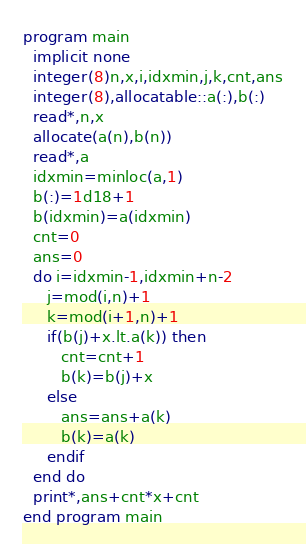Convert code to text. <code><loc_0><loc_0><loc_500><loc_500><_FORTRAN_>program main
  implicit none
  integer(8)n,x,i,idxmin,j,k,cnt,ans
  integer(8),allocatable::a(:),b(:)
  read*,n,x
  allocate(a(n),b(n))
  read*,a
  idxmin=minloc(a,1)
  b(:)=1d18+1
  b(idxmin)=a(idxmin)
  cnt=0
  ans=0
  do i=idxmin-1,idxmin+n-2
     j=mod(i,n)+1
     k=mod(i+1,n)+1
     if(b(j)+x.lt.a(k)) then
        cnt=cnt+1
        b(k)=b(j)+x
     else
        ans=ans+a(k)
        b(k)=a(k)
     endif
  end do
  print*,ans+cnt*x+cnt
end program main
</code> 